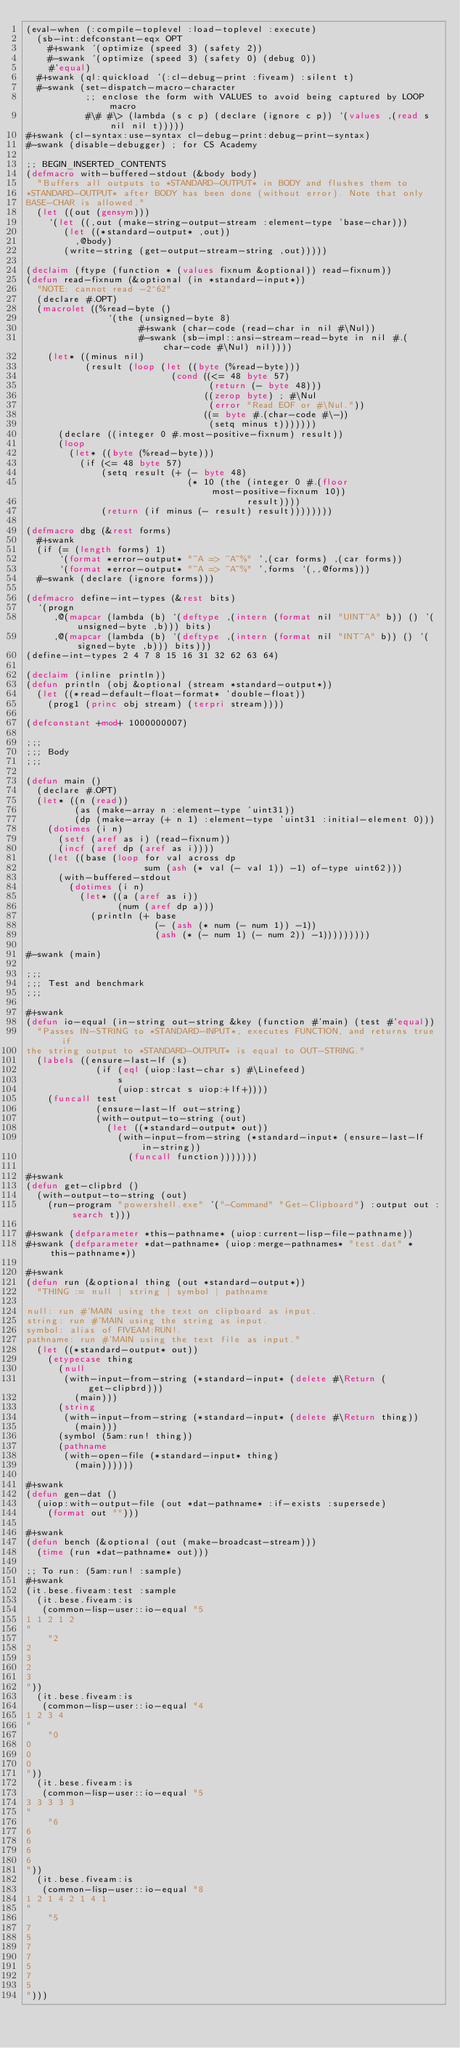Convert code to text. <code><loc_0><loc_0><loc_500><loc_500><_Lisp_>(eval-when (:compile-toplevel :load-toplevel :execute)
  (sb-int:defconstant-eqx OPT
    #+swank '(optimize (speed 3) (safety 2))
    #-swank '(optimize (speed 3) (safety 0) (debug 0))
    #'equal)
  #+swank (ql:quickload '(:cl-debug-print :fiveam) :silent t)
  #-swank (set-dispatch-macro-character
           ;; enclose the form with VALUES to avoid being captured by LOOP macro
           #\# #\> (lambda (s c p) (declare (ignore c p)) `(values ,(read s nil nil t)))))
#+swank (cl-syntax:use-syntax cl-debug-print:debug-print-syntax)
#-swank (disable-debugger) ; for CS Academy

;; BEGIN_INSERTED_CONTENTS
(defmacro with-buffered-stdout (&body body)
  "Buffers all outputs to *STANDARD-OUTPUT* in BODY and flushes them to
*STANDARD-OUTPUT* after BODY has been done (without error). Note that only
BASE-CHAR is allowed."
  (let ((out (gensym)))
    `(let ((,out (make-string-output-stream :element-type 'base-char)))
       (let ((*standard-output* ,out))
         ,@body)
       (write-string (get-output-stream-string ,out)))))

(declaim (ftype (function * (values fixnum &optional)) read-fixnum))
(defun read-fixnum (&optional (in *standard-input*))
  "NOTE: cannot read -2^62"
  (declare #.OPT)
  (macrolet ((%read-byte ()
               `(the (unsigned-byte 8)
                     #+swank (char-code (read-char in nil #\Nul))
                     #-swank (sb-impl::ansi-stream-read-byte in nil #.(char-code #\Nul) nil))))
    (let* ((minus nil)
           (result (loop (let ((byte (%read-byte)))
                           (cond ((<= 48 byte 57)
                                  (return (- byte 48)))
                                 ((zerop byte) ; #\Nul
                                  (error "Read EOF or #\Nul."))
                                 ((= byte #.(char-code #\-))
                                  (setq minus t)))))))
      (declare ((integer 0 #.most-positive-fixnum) result))
      (loop
        (let* ((byte (%read-byte)))
          (if (<= 48 byte 57)
              (setq result (+ (- byte 48)
                              (* 10 (the (integer 0 #.(floor most-positive-fixnum 10))
                                         result))))
              (return (if minus (- result) result))))))))

(defmacro dbg (&rest forms)
  #+swank
  (if (= (length forms) 1)
      `(format *error-output* "~A => ~A~%" ',(car forms) ,(car forms))
      `(format *error-output* "~A => ~A~%" ',forms `(,,@forms)))
  #-swank (declare (ignore forms)))

(defmacro define-int-types (&rest bits)
  `(progn
     ,@(mapcar (lambda (b) `(deftype ,(intern (format nil "UINT~A" b)) () '(unsigned-byte ,b))) bits)
     ,@(mapcar (lambda (b) `(deftype ,(intern (format nil "INT~A" b)) () '(signed-byte ,b))) bits)))
(define-int-types 2 4 7 8 15 16 31 32 62 63 64)

(declaim (inline println))
(defun println (obj &optional (stream *standard-output*))
  (let ((*read-default-float-format* 'double-float))
    (prog1 (princ obj stream) (terpri stream))))

(defconstant +mod+ 1000000007)

;;;
;;; Body
;;;

(defun main ()
  (declare #.OPT)
  (let* ((n (read))
         (as (make-array n :element-type 'uint31))
         (dp (make-array (+ n 1) :element-type 'uint31 :initial-element 0)))
    (dotimes (i n)
      (setf (aref as i) (read-fixnum))
      (incf (aref dp (aref as i))))
    (let ((base (loop for val across dp
                      sum (ash (* val (- val 1)) -1) of-type uint62)))
      (with-buffered-stdout
        (dotimes (i n)
          (let* ((a (aref as i))
                 (num (aref dp a)))
            (println (+ base
                        (- (ash (* num (- num 1)) -1))
                        (ash (* (- num 1) (- num 2)) -1)))))))))

#-swank (main)

;;;
;;; Test and benchmark
;;;

#+swank
(defun io-equal (in-string out-string &key (function #'main) (test #'equal))
  "Passes IN-STRING to *STANDARD-INPUT*, executes FUNCTION, and returns true if
the string output to *STANDARD-OUTPUT* is equal to OUT-STRING."
  (labels ((ensure-last-lf (s)
             (if (eql (uiop:last-char s) #\Linefeed)
                 s
                 (uiop:strcat s uiop:+lf+))))
    (funcall test
             (ensure-last-lf out-string)
             (with-output-to-string (out)
               (let ((*standard-output* out))
                 (with-input-from-string (*standard-input* (ensure-last-lf in-string))
                   (funcall function)))))))

#+swank
(defun get-clipbrd ()
  (with-output-to-string (out)
    (run-program "powershell.exe" '("-Command" "Get-Clipboard") :output out :search t)))

#+swank (defparameter *this-pathname* (uiop:current-lisp-file-pathname))
#+swank (defparameter *dat-pathname* (uiop:merge-pathnames* "test.dat" *this-pathname*))

#+swank
(defun run (&optional thing (out *standard-output*))
  "THING := null | string | symbol | pathname

null: run #'MAIN using the text on clipboard as input.
string: run #'MAIN using the string as input.
symbol: alias of FIVEAM:RUN!.
pathname: run #'MAIN using the text file as input."
  (let ((*standard-output* out))
    (etypecase thing
      (null
       (with-input-from-string (*standard-input* (delete #\Return (get-clipbrd)))
         (main)))
      (string
       (with-input-from-string (*standard-input* (delete #\Return thing))
         (main)))
      (symbol (5am:run! thing))
      (pathname
       (with-open-file (*standard-input* thing)
         (main))))))

#+swank
(defun gen-dat ()
  (uiop:with-output-file (out *dat-pathname* :if-exists :supersede)
    (format out "")))

#+swank
(defun bench (&optional (out (make-broadcast-stream)))
  (time (run *dat-pathname* out)))

;; To run: (5am:run! :sample)
#+swank
(it.bese.fiveam:test :sample
  (it.bese.fiveam:is
   (common-lisp-user::io-equal "5
1 1 2 1 2
"
    "2
2
3
2
3
"))
  (it.bese.fiveam:is
   (common-lisp-user::io-equal "4
1 2 3 4
"
    "0
0
0
0
"))
  (it.bese.fiveam:is
   (common-lisp-user::io-equal "5
3 3 3 3 3
"
    "6
6
6
6
6
"))
  (it.bese.fiveam:is
   (common-lisp-user::io-equal "8
1 2 1 4 2 1 4 1
"
    "5
7
5
7
7
5
7
5
")))
</code> 